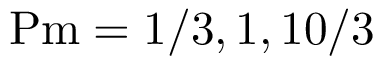<formula> <loc_0><loc_0><loc_500><loc_500>P m = 1 / 3 , 1 , 1 0 / 3</formula> 